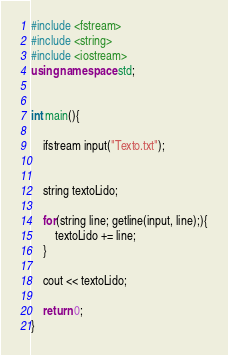<code> <loc_0><loc_0><loc_500><loc_500><_C++_>#include <fstream>
#include <string>
#include <iostream>
using namespace std;


int main(){

    ifstream input("Texto.txt");


    string textoLido;

    for(string line; getline(input, line);){
        textoLido += line;
    }

    cout << textoLido;

    return 0;
}

</code> 